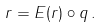<formula> <loc_0><loc_0><loc_500><loc_500>r = E ( r ) \circ q \, .</formula> 